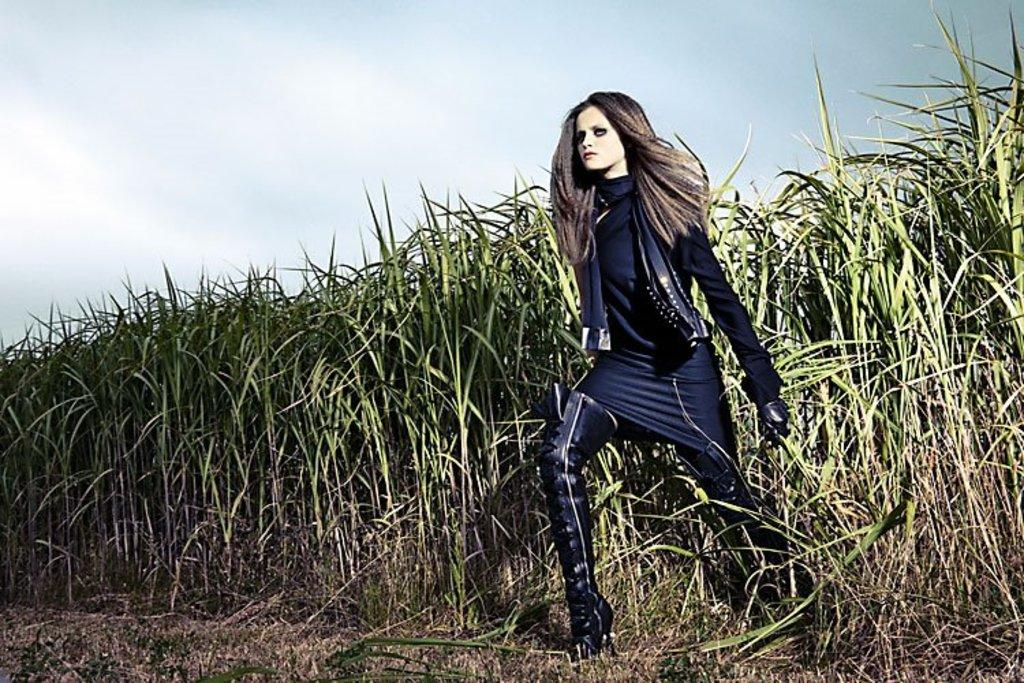Who is the main subject in the image? There is a woman in the image. What is the woman wearing? The woman is wearing a black dress. Where is the woman standing? The woman is standing on the ground. What type of vegetation can be seen in the image? There is grass and plants visible in the image. What can be seen in the background of the image? The sky is visible in the background of the image. How many sisters does the woman have in the image? There is no information about the woman's sisters in the image. Can you see any worms crawling on the ground in the image? There are no worms visible in the image. 